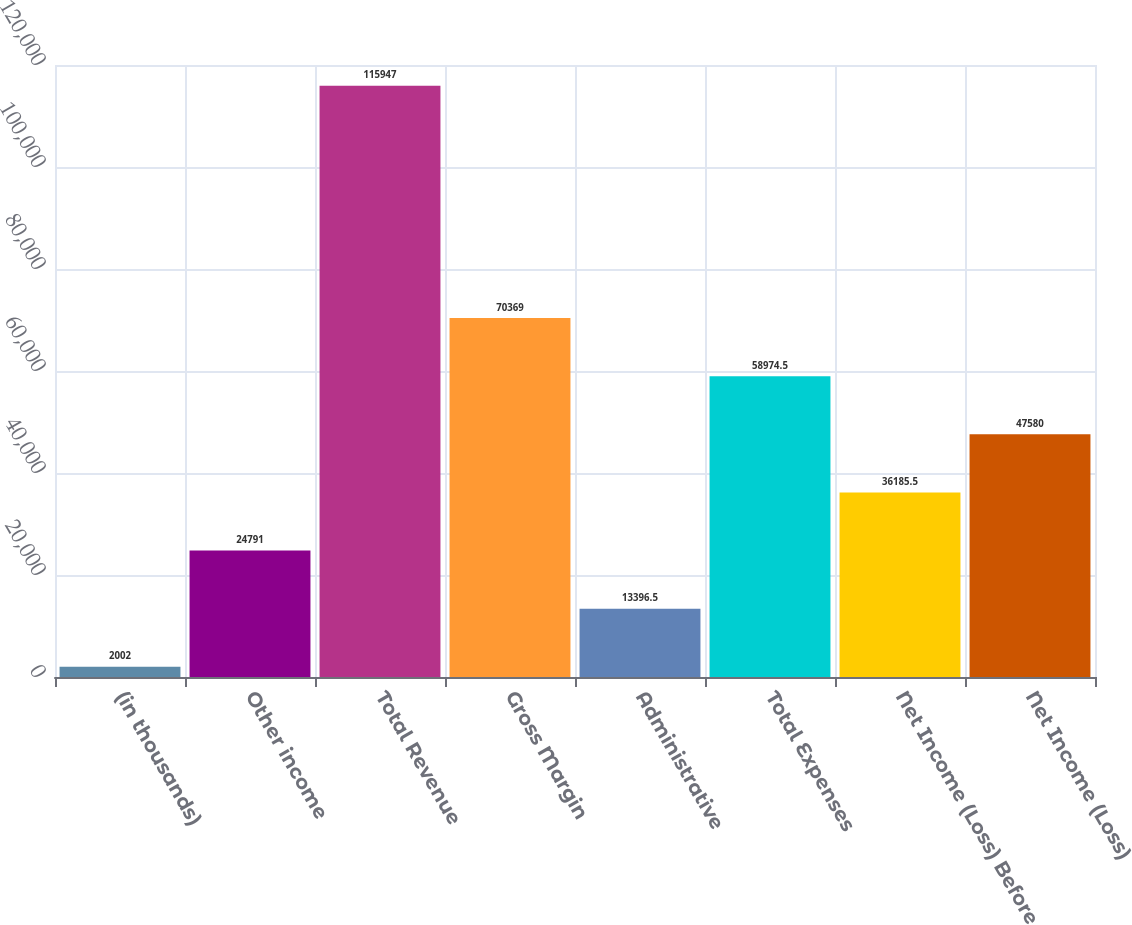Convert chart to OTSL. <chart><loc_0><loc_0><loc_500><loc_500><bar_chart><fcel>(in thousands)<fcel>Other income<fcel>Total Revenue<fcel>Gross Margin<fcel>Administrative<fcel>Total Expenses<fcel>Net Income (Loss) Before<fcel>Net Income (Loss)<nl><fcel>2002<fcel>24791<fcel>115947<fcel>70369<fcel>13396.5<fcel>58974.5<fcel>36185.5<fcel>47580<nl></chart> 